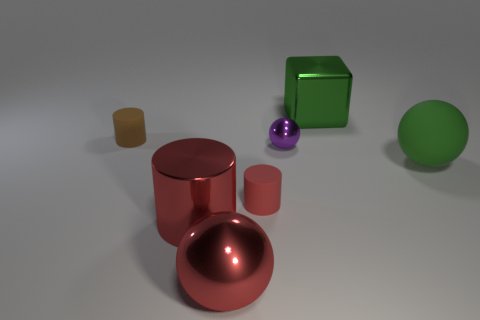Is the color of the metal cylinder the same as the big shiny sphere?
Your answer should be compact. Yes. What is the material of the big cube that is the same color as the rubber ball?
Your response must be concise. Metal. There is a thing that is both on the left side of the purple metallic ball and behind the tiny purple ball; what is its size?
Offer a very short reply. Small. There is a purple shiny object that is the same size as the brown rubber cylinder; what is its shape?
Keep it short and to the point. Sphere. There is a large cylinder right of the rubber object left of the big sphere that is to the left of the big green cube; what is it made of?
Your response must be concise. Metal. There is a rubber object behind the green sphere; does it have the same shape as the small rubber thing in front of the brown rubber thing?
Give a very brief answer. Yes. How many other things are there of the same material as the large green sphere?
Your response must be concise. 2. Are the large ball that is on the left side of the green metallic object and the tiny red thing that is to the right of the large shiny cylinder made of the same material?
Provide a succinct answer. No. What is the shape of the purple thing that is the same material as the big red cylinder?
Provide a succinct answer. Sphere. Is there anything else that has the same color as the rubber ball?
Offer a terse response. Yes. 